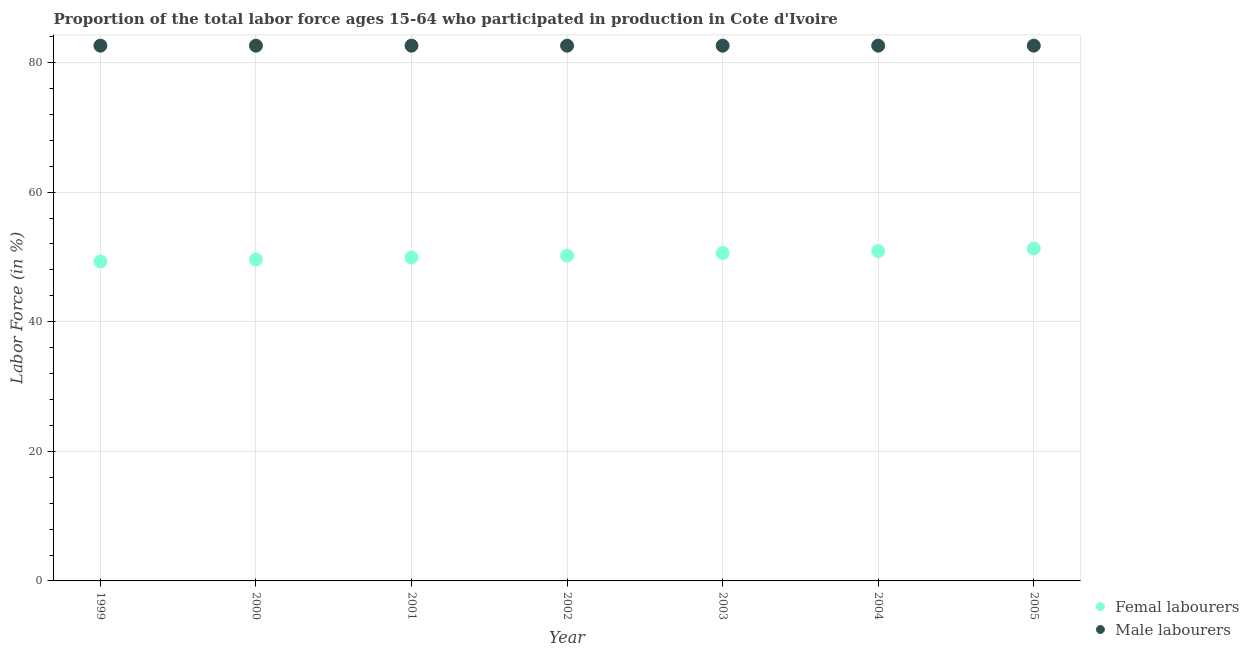What is the percentage of male labour force in 2000?
Provide a succinct answer. 82.6. Across all years, what is the maximum percentage of male labour force?
Your response must be concise. 82.6. Across all years, what is the minimum percentage of male labour force?
Your answer should be very brief. 82.6. What is the total percentage of male labour force in the graph?
Keep it short and to the point. 578.2. What is the difference between the percentage of male labour force in 2002 and the percentage of female labor force in 2004?
Your response must be concise. 31.7. What is the average percentage of female labor force per year?
Your answer should be very brief. 50.26. In the year 2004, what is the difference between the percentage of male labour force and percentage of female labor force?
Keep it short and to the point. 31.7. In how many years, is the percentage of female labor force greater than 12 %?
Provide a short and direct response. 7. What is the ratio of the percentage of male labour force in 2004 to that in 2005?
Provide a short and direct response. 1. Is the percentage of male labour force in 2002 less than that in 2004?
Give a very brief answer. No. Is the difference between the percentage of male labour force in 1999 and 2002 greater than the difference between the percentage of female labor force in 1999 and 2002?
Your answer should be compact. Yes. What is the difference between the highest and the second highest percentage of female labor force?
Provide a succinct answer. 0.4. What is the difference between the highest and the lowest percentage of female labor force?
Ensure brevity in your answer.  2. In how many years, is the percentage of male labour force greater than the average percentage of male labour force taken over all years?
Keep it short and to the point. 0. Is the sum of the percentage of male labour force in 2003 and 2005 greater than the maximum percentage of female labor force across all years?
Give a very brief answer. Yes. Is the percentage of male labour force strictly less than the percentage of female labor force over the years?
Offer a very short reply. No. Are the values on the major ticks of Y-axis written in scientific E-notation?
Your answer should be very brief. No. Does the graph contain any zero values?
Your response must be concise. No. How many legend labels are there?
Offer a very short reply. 2. How are the legend labels stacked?
Keep it short and to the point. Vertical. What is the title of the graph?
Your answer should be very brief. Proportion of the total labor force ages 15-64 who participated in production in Cote d'Ivoire. What is the Labor Force (in %) of Femal labourers in 1999?
Give a very brief answer. 49.3. What is the Labor Force (in %) in Male labourers in 1999?
Provide a succinct answer. 82.6. What is the Labor Force (in %) in Femal labourers in 2000?
Your answer should be very brief. 49.6. What is the Labor Force (in %) of Male labourers in 2000?
Provide a short and direct response. 82.6. What is the Labor Force (in %) in Femal labourers in 2001?
Your answer should be very brief. 49.9. What is the Labor Force (in %) of Male labourers in 2001?
Your answer should be very brief. 82.6. What is the Labor Force (in %) in Femal labourers in 2002?
Provide a succinct answer. 50.2. What is the Labor Force (in %) in Male labourers in 2002?
Offer a terse response. 82.6. What is the Labor Force (in %) in Femal labourers in 2003?
Offer a very short reply. 50.6. What is the Labor Force (in %) of Male labourers in 2003?
Make the answer very short. 82.6. What is the Labor Force (in %) in Femal labourers in 2004?
Your answer should be compact. 50.9. What is the Labor Force (in %) in Male labourers in 2004?
Give a very brief answer. 82.6. What is the Labor Force (in %) of Femal labourers in 2005?
Your answer should be very brief. 51.3. What is the Labor Force (in %) in Male labourers in 2005?
Your response must be concise. 82.6. Across all years, what is the maximum Labor Force (in %) of Femal labourers?
Offer a terse response. 51.3. Across all years, what is the maximum Labor Force (in %) in Male labourers?
Your answer should be compact. 82.6. Across all years, what is the minimum Labor Force (in %) in Femal labourers?
Your answer should be very brief. 49.3. Across all years, what is the minimum Labor Force (in %) of Male labourers?
Keep it short and to the point. 82.6. What is the total Labor Force (in %) of Femal labourers in the graph?
Offer a very short reply. 351.8. What is the total Labor Force (in %) of Male labourers in the graph?
Make the answer very short. 578.2. What is the difference between the Labor Force (in %) of Male labourers in 1999 and that in 2001?
Provide a short and direct response. 0. What is the difference between the Labor Force (in %) in Femal labourers in 1999 and that in 2002?
Your answer should be compact. -0.9. What is the difference between the Labor Force (in %) in Femal labourers in 1999 and that in 2003?
Keep it short and to the point. -1.3. What is the difference between the Labor Force (in %) of Male labourers in 1999 and that in 2003?
Offer a terse response. 0. What is the difference between the Labor Force (in %) in Male labourers in 1999 and that in 2004?
Ensure brevity in your answer.  0. What is the difference between the Labor Force (in %) in Femal labourers in 1999 and that in 2005?
Offer a terse response. -2. What is the difference between the Labor Force (in %) in Male labourers in 1999 and that in 2005?
Your answer should be compact. 0. What is the difference between the Labor Force (in %) in Male labourers in 2000 and that in 2001?
Your response must be concise. 0. What is the difference between the Labor Force (in %) of Male labourers in 2000 and that in 2003?
Offer a very short reply. 0. What is the difference between the Labor Force (in %) of Femal labourers in 2000 and that in 2004?
Your response must be concise. -1.3. What is the difference between the Labor Force (in %) in Male labourers in 2000 and that in 2004?
Ensure brevity in your answer.  0. What is the difference between the Labor Force (in %) in Male labourers in 2000 and that in 2005?
Provide a short and direct response. 0. What is the difference between the Labor Force (in %) of Male labourers in 2001 and that in 2002?
Provide a succinct answer. 0. What is the difference between the Labor Force (in %) in Male labourers in 2001 and that in 2005?
Keep it short and to the point. 0. What is the difference between the Labor Force (in %) of Femal labourers in 2002 and that in 2005?
Provide a short and direct response. -1.1. What is the difference between the Labor Force (in %) in Male labourers in 2002 and that in 2005?
Provide a succinct answer. 0. What is the difference between the Labor Force (in %) of Femal labourers in 2003 and that in 2004?
Keep it short and to the point. -0.3. What is the difference between the Labor Force (in %) of Male labourers in 2003 and that in 2004?
Your answer should be compact. 0. What is the difference between the Labor Force (in %) of Femal labourers in 1999 and the Labor Force (in %) of Male labourers in 2000?
Offer a terse response. -33.3. What is the difference between the Labor Force (in %) of Femal labourers in 1999 and the Labor Force (in %) of Male labourers in 2001?
Your answer should be compact. -33.3. What is the difference between the Labor Force (in %) of Femal labourers in 1999 and the Labor Force (in %) of Male labourers in 2002?
Provide a short and direct response. -33.3. What is the difference between the Labor Force (in %) of Femal labourers in 1999 and the Labor Force (in %) of Male labourers in 2003?
Keep it short and to the point. -33.3. What is the difference between the Labor Force (in %) of Femal labourers in 1999 and the Labor Force (in %) of Male labourers in 2004?
Keep it short and to the point. -33.3. What is the difference between the Labor Force (in %) of Femal labourers in 1999 and the Labor Force (in %) of Male labourers in 2005?
Offer a very short reply. -33.3. What is the difference between the Labor Force (in %) of Femal labourers in 2000 and the Labor Force (in %) of Male labourers in 2001?
Offer a very short reply. -33. What is the difference between the Labor Force (in %) of Femal labourers in 2000 and the Labor Force (in %) of Male labourers in 2002?
Provide a short and direct response. -33. What is the difference between the Labor Force (in %) in Femal labourers in 2000 and the Labor Force (in %) in Male labourers in 2003?
Make the answer very short. -33. What is the difference between the Labor Force (in %) in Femal labourers in 2000 and the Labor Force (in %) in Male labourers in 2004?
Your answer should be compact. -33. What is the difference between the Labor Force (in %) in Femal labourers in 2000 and the Labor Force (in %) in Male labourers in 2005?
Keep it short and to the point. -33. What is the difference between the Labor Force (in %) in Femal labourers in 2001 and the Labor Force (in %) in Male labourers in 2002?
Offer a terse response. -32.7. What is the difference between the Labor Force (in %) of Femal labourers in 2001 and the Labor Force (in %) of Male labourers in 2003?
Your response must be concise. -32.7. What is the difference between the Labor Force (in %) in Femal labourers in 2001 and the Labor Force (in %) in Male labourers in 2004?
Offer a very short reply. -32.7. What is the difference between the Labor Force (in %) in Femal labourers in 2001 and the Labor Force (in %) in Male labourers in 2005?
Offer a very short reply. -32.7. What is the difference between the Labor Force (in %) in Femal labourers in 2002 and the Labor Force (in %) in Male labourers in 2003?
Keep it short and to the point. -32.4. What is the difference between the Labor Force (in %) in Femal labourers in 2002 and the Labor Force (in %) in Male labourers in 2004?
Provide a short and direct response. -32.4. What is the difference between the Labor Force (in %) of Femal labourers in 2002 and the Labor Force (in %) of Male labourers in 2005?
Your answer should be compact. -32.4. What is the difference between the Labor Force (in %) in Femal labourers in 2003 and the Labor Force (in %) in Male labourers in 2004?
Provide a short and direct response. -32. What is the difference between the Labor Force (in %) of Femal labourers in 2003 and the Labor Force (in %) of Male labourers in 2005?
Give a very brief answer. -32. What is the difference between the Labor Force (in %) in Femal labourers in 2004 and the Labor Force (in %) in Male labourers in 2005?
Your response must be concise. -31.7. What is the average Labor Force (in %) of Femal labourers per year?
Provide a short and direct response. 50.26. What is the average Labor Force (in %) in Male labourers per year?
Provide a short and direct response. 82.6. In the year 1999, what is the difference between the Labor Force (in %) in Femal labourers and Labor Force (in %) in Male labourers?
Offer a terse response. -33.3. In the year 2000, what is the difference between the Labor Force (in %) of Femal labourers and Labor Force (in %) of Male labourers?
Offer a very short reply. -33. In the year 2001, what is the difference between the Labor Force (in %) of Femal labourers and Labor Force (in %) of Male labourers?
Your answer should be very brief. -32.7. In the year 2002, what is the difference between the Labor Force (in %) of Femal labourers and Labor Force (in %) of Male labourers?
Provide a short and direct response. -32.4. In the year 2003, what is the difference between the Labor Force (in %) in Femal labourers and Labor Force (in %) in Male labourers?
Ensure brevity in your answer.  -32. In the year 2004, what is the difference between the Labor Force (in %) in Femal labourers and Labor Force (in %) in Male labourers?
Make the answer very short. -31.7. In the year 2005, what is the difference between the Labor Force (in %) of Femal labourers and Labor Force (in %) of Male labourers?
Provide a succinct answer. -31.3. What is the ratio of the Labor Force (in %) of Femal labourers in 1999 to that in 2001?
Offer a terse response. 0.99. What is the ratio of the Labor Force (in %) in Male labourers in 1999 to that in 2001?
Offer a very short reply. 1. What is the ratio of the Labor Force (in %) of Femal labourers in 1999 to that in 2002?
Provide a succinct answer. 0.98. What is the ratio of the Labor Force (in %) in Male labourers in 1999 to that in 2002?
Your answer should be compact. 1. What is the ratio of the Labor Force (in %) in Femal labourers in 1999 to that in 2003?
Ensure brevity in your answer.  0.97. What is the ratio of the Labor Force (in %) in Femal labourers in 1999 to that in 2004?
Ensure brevity in your answer.  0.97. What is the ratio of the Labor Force (in %) in Male labourers in 1999 to that in 2004?
Your answer should be very brief. 1. What is the ratio of the Labor Force (in %) in Femal labourers in 1999 to that in 2005?
Offer a terse response. 0.96. What is the ratio of the Labor Force (in %) of Male labourers in 1999 to that in 2005?
Give a very brief answer. 1. What is the ratio of the Labor Force (in %) of Femal labourers in 2000 to that in 2001?
Ensure brevity in your answer.  0.99. What is the ratio of the Labor Force (in %) of Femal labourers in 2000 to that in 2002?
Ensure brevity in your answer.  0.99. What is the ratio of the Labor Force (in %) in Femal labourers in 2000 to that in 2003?
Offer a terse response. 0.98. What is the ratio of the Labor Force (in %) of Male labourers in 2000 to that in 2003?
Ensure brevity in your answer.  1. What is the ratio of the Labor Force (in %) in Femal labourers in 2000 to that in 2004?
Keep it short and to the point. 0.97. What is the ratio of the Labor Force (in %) of Male labourers in 2000 to that in 2004?
Your answer should be compact. 1. What is the ratio of the Labor Force (in %) in Femal labourers in 2000 to that in 2005?
Give a very brief answer. 0.97. What is the ratio of the Labor Force (in %) of Femal labourers in 2001 to that in 2002?
Provide a short and direct response. 0.99. What is the ratio of the Labor Force (in %) of Femal labourers in 2001 to that in 2003?
Make the answer very short. 0.99. What is the ratio of the Labor Force (in %) of Male labourers in 2001 to that in 2003?
Provide a short and direct response. 1. What is the ratio of the Labor Force (in %) in Femal labourers in 2001 to that in 2004?
Offer a terse response. 0.98. What is the ratio of the Labor Force (in %) in Male labourers in 2001 to that in 2004?
Offer a terse response. 1. What is the ratio of the Labor Force (in %) of Femal labourers in 2001 to that in 2005?
Make the answer very short. 0.97. What is the ratio of the Labor Force (in %) of Male labourers in 2001 to that in 2005?
Offer a terse response. 1. What is the ratio of the Labor Force (in %) in Femal labourers in 2002 to that in 2004?
Offer a terse response. 0.99. What is the ratio of the Labor Force (in %) of Femal labourers in 2002 to that in 2005?
Provide a short and direct response. 0.98. What is the ratio of the Labor Force (in %) of Femal labourers in 2003 to that in 2005?
Make the answer very short. 0.99. What is the ratio of the Labor Force (in %) in Male labourers in 2003 to that in 2005?
Keep it short and to the point. 1. What is the ratio of the Labor Force (in %) in Femal labourers in 2004 to that in 2005?
Give a very brief answer. 0.99. What is the ratio of the Labor Force (in %) of Male labourers in 2004 to that in 2005?
Provide a short and direct response. 1. What is the difference between the highest and the second highest Labor Force (in %) of Femal labourers?
Offer a terse response. 0.4. What is the difference between the highest and the lowest Labor Force (in %) in Male labourers?
Offer a terse response. 0. 